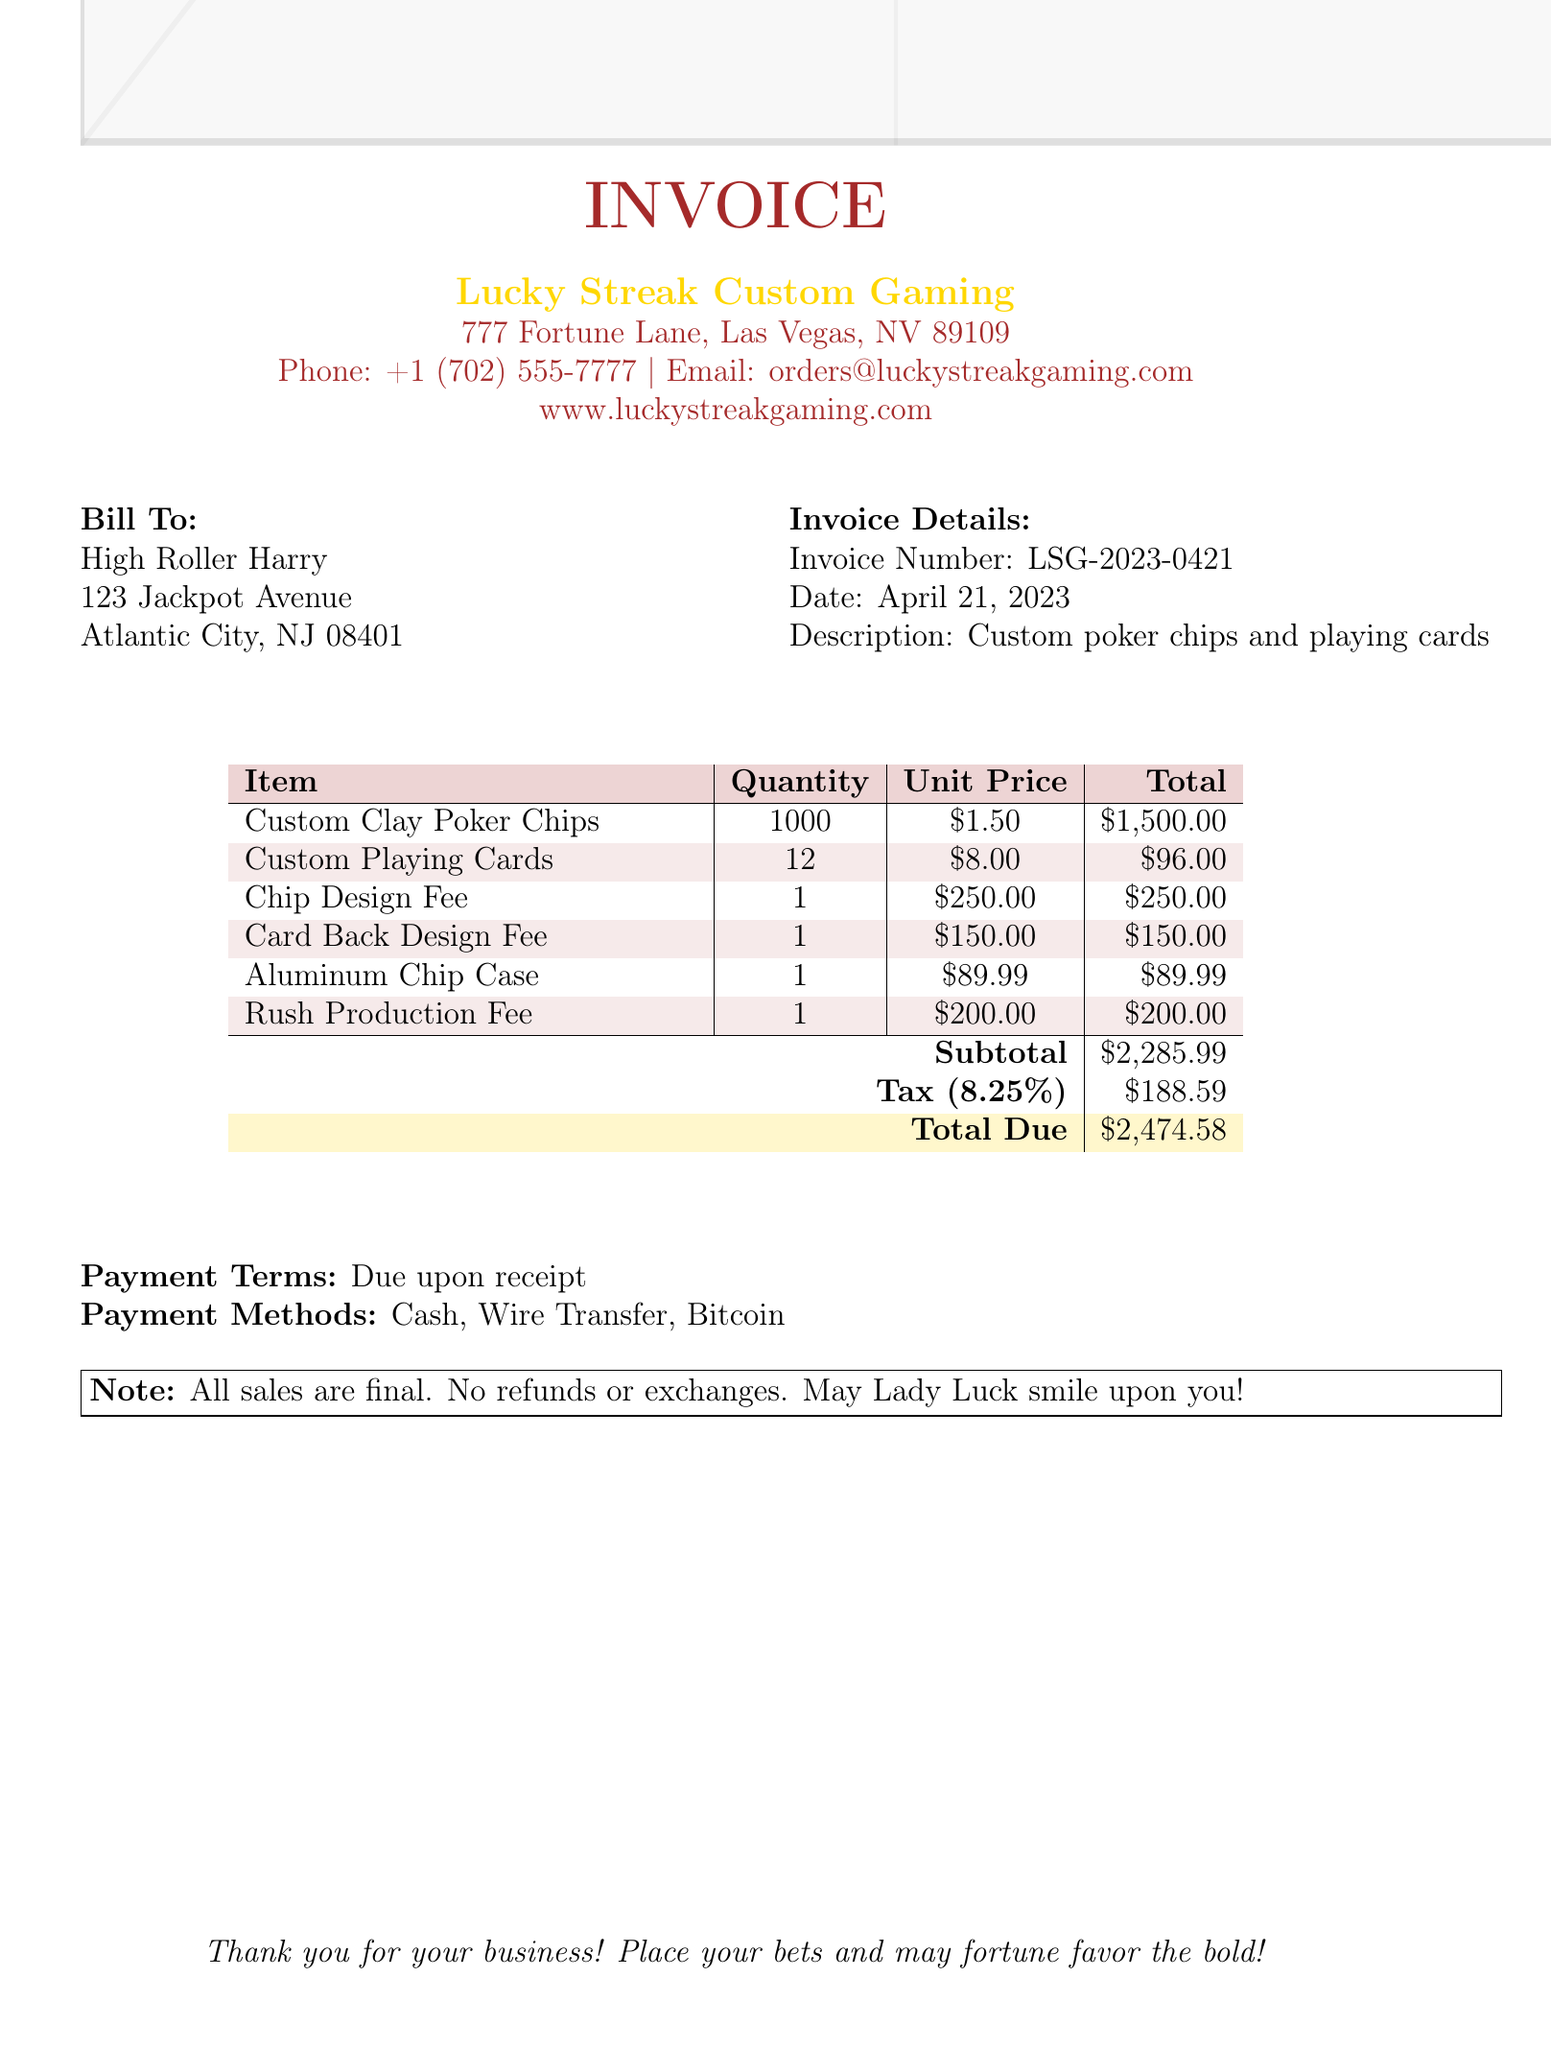What is the invoice number? The invoice number can be found in the invoice details section, which states "Invoice Number: LSG-2023-0421".
Answer: LSG-2023-0421 What is the total amount due? The total amount due is provided in the payment summary of the invoice, shown as "Total Due: $2,474.58".
Answer: $2,474.58 Who is the client? The client's information is located in the bill to section, which states "High Roller Harry".
Answer: High Roller Harry What is the date of the invoice? The date is mentioned in the invoice details section as "Date: April 21, 2023".
Answer: April 21, 2023 What is the tax rate applied? The tax rate is listed in the payment summary as "Tax (8.25%)".
Answer: 8.25% How many custom poker chips were ordered? The quantity of custom poker chips is indicated in the items section under "Custom Clay Poker Chips", which shows "Quantity: 1000".
Answer: 1000 What is the purpose of the Rush Production Fee? The Rush Production Fee details state it is for "Expedited production and shipping for delivery within 7 business days".
Answer: Expedited production and shipping What is the subtotal of the invoice? The subtotal appears in the payment summary, specified as "Subtotal: $2,285.99".
Answer: $2,285.99 What payment methods are accepted? The accepted payment methods are outlined in the payment terms section: "Cash, Wire Transfer, Bitcoin".
Answer: Cash, Wire Transfer, Bitcoin 